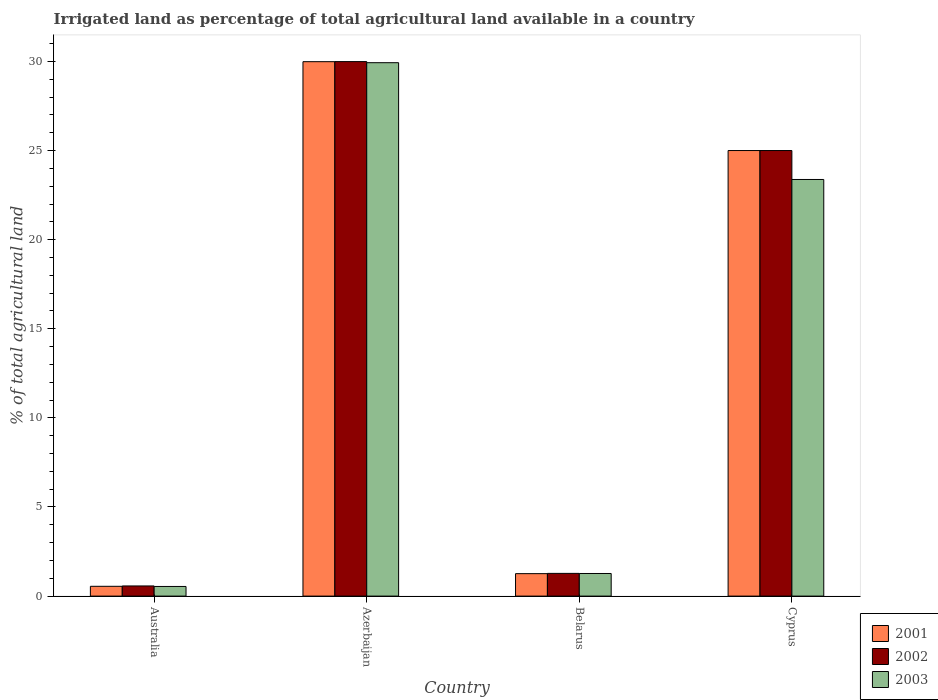Are the number of bars per tick equal to the number of legend labels?
Ensure brevity in your answer.  Yes. Are the number of bars on each tick of the X-axis equal?
Keep it short and to the point. Yes. How many bars are there on the 2nd tick from the right?
Provide a short and direct response. 3. What is the label of the 4th group of bars from the left?
Offer a very short reply. Cyprus. What is the percentage of irrigated land in 2002 in Belarus?
Your answer should be very brief. 1.27. Across all countries, what is the maximum percentage of irrigated land in 2001?
Your answer should be very brief. 29.99. Across all countries, what is the minimum percentage of irrigated land in 2003?
Keep it short and to the point. 0.54. In which country was the percentage of irrigated land in 2002 maximum?
Your answer should be compact. Azerbaijan. In which country was the percentage of irrigated land in 2001 minimum?
Offer a very short reply. Australia. What is the total percentage of irrigated land in 2001 in the graph?
Ensure brevity in your answer.  56.8. What is the difference between the percentage of irrigated land in 2002 in Australia and that in Cyprus?
Ensure brevity in your answer.  -24.43. What is the difference between the percentage of irrigated land in 2003 in Azerbaijan and the percentage of irrigated land in 2001 in Australia?
Keep it short and to the point. 29.38. What is the average percentage of irrigated land in 2001 per country?
Make the answer very short. 14.2. What is the difference between the percentage of irrigated land of/in 2002 and percentage of irrigated land of/in 2003 in Australia?
Give a very brief answer. 0.03. In how many countries, is the percentage of irrigated land in 2003 greater than 25 %?
Offer a terse response. 1. What is the ratio of the percentage of irrigated land in 2001 in Australia to that in Cyprus?
Keep it short and to the point. 0.02. Is the difference between the percentage of irrigated land in 2002 in Australia and Cyprus greater than the difference between the percentage of irrigated land in 2003 in Australia and Cyprus?
Your answer should be very brief. No. What is the difference between the highest and the second highest percentage of irrigated land in 2002?
Your answer should be compact. -4.99. What is the difference between the highest and the lowest percentage of irrigated land in 2001?
Provide a short and direct response. 29.44. Is the sum of the percentage of irrigated land in 2003 in Australia and Cyprus greater than the maximum percentage of irrigated land in 2001 across all countries?
Offer a very short reply. No. What does the 2nd bar from the right in Azerbaijan represents?
Give a very brief answer. 2002. How many bars are there?
Make the answer very short. 12. How many countries are there in the graph?
Give a very brief answer. 4. What is the difference between two consecutive major ticks on the Y-axis?
Provide a short and direct response. 5. Are the values on the major ticks of Y-axis written in scientific E-notation?
Offer a terse response. No. Does the graph contain any zero values?
Make the answer very short. No. How many legend labels are there?
Make the answer very short. 3. What is the title of the graph?
Ensure brevity in your answer.  Irrigated land as percentage of total agricultural land available in a country. Does "1966" appear as one of the legend labels in the graph?
Offer a terse response. No. What is the label or title of the X-axis?
Your response must be concise. Country. What is the label or title of the Y-axis?
Provide a short and direct response. % of total agricultural land. What is the % of total agricultural land of 2001 in Australia?
Offer a very short reply. 0.55. What is the % of total agricultural land of 2002 in Australia?
Offer a very short reply. 0.57. What is the % of total agricultural land of 2003 in Australia?
Your answer should be compact. 0.54. What is the % of total agricultural land of 2001 in Azerbaijan?
Offer a very short reply. 29.99. What is the % of total agricultural land in 2002 in Azerbaijan?
Keep it short and to the point. 29.99. What is the % of total agricultural land of 2003 in Azerbaijan?
Provide a succinct answer. 29.93. What is the % of total agricultural land of 2001 in Belarus?
Provide a succinct answer. 1.26. What is the % of total agricultural land in 2002 in Belarus?
Your response must be concise. 1.27. What is the % of total agricultural land in 2003 in Belarus?
Provide a succinct answer. 1.27. What is the % of total agricultural land of 2002 in Cyprus?
Provide a short and direct response. 25. What is the % of total agricultural land in 2003 in Cyprus?
Make the answer very short. 23.38. Across all countries, what is the maximum % of total agricultural land of 2001?
Your answer should be very brief. 29.99. Across all countries, what is the maximum % of total agricultural land in 2002?
Your answer should be very brief. 29.99. Across all countries, what is the maximum % of total agricultural land in 2003?
Your answer should be compact. 29.93. Across all countries, what is the minimum % of total agricultural land of 2001?
Your answer should be very brief. 0.55. Across all countries, what is the minimum % of total agricultural land of 2002?
Your answer should be very brief. 0.57. Across all countries, what is the minimum % of total agricultural land of 2003?
Your answer should be compact. 0.54. What is the total % of total agricultural land of 2001 in the graph?
Offer a very short reply. 56.8. What is the total % of total agricultural land of 2002 in the graph?
Keep it short and to the point. 56.83. What is the total % of total agricultural land of 2003 in the graph?
Give a very brief answer. 55.12. What is the difference between the % of total agricultural land of 2001 in Australia and that in Azerbaijan?
Offer a very short reply. -29.44. What is the difference between the % of total agricultural land of 2002 in Australia and that in Azerbaijan?
Your answer should be compact. -29.42. What is the difference between the % of total agricultural land of 2003 in Australia and that in Azerbaijan?
Your answer should be very brief. -29.39. What is the difference between the % of total agricultural land of 2001 in Australia and that in Belarus?
Your answer should be very brief. -0.71. What is the difference between the % of total agricultural land in 2002 in Australia and that in Belarus?
Ensure brevity in your answer.  -0.7. What is the difference between the % of total agricultural land in 2003 in Australia and that in Belarus?
Make the answer very short. -0.73. What is the difference between the % of total agricultural land of 2001 in Australia and that in Cyprus?
Your answer should be very brief. -24.45. What is the difference between the % of total agricultural land in 2002 in Australia and that in Cyprus?
Give a very brief answer. -24.43. What is the difference between the % of total agricultural land in 2003 in Australia and that in Cyprus?
Offer a terse response. -22.84. What is the difference between the % of total agricultural land of 2001 in Azerbaijan and that in Belarus?
Give a very brief answer. 28.73. What is the difference between the % of total agricultural land in 2002 in Azerbaijan and that in Belarus?
Make the answer very short. 28.72. What is the difference between the % of total agricultural land of 2003 in Azerbaijan and that in Belarus?
Make the answer very short. 28.66. What is the difference between the % of total agricultural land of 2001 in Azerbaijan and that in Cyprus?
Offer a very short reply. 4.99. What is the difference between the % of total agricultural land of 2002 in Azerbaijan and that in Cyprus?
Ensure brevity in your answer.  4.99. What is the difference between the % of total agricultural land of 2003 in Azerbaijan and that in Cyprus?
Offer a terse response. 6.55. What is the difference between the % of total agricultural land of 2001 in Belarus and that in Cyprus?
Give a very brief answer. -23.74. What is the difference between the % of total agricultural land in 2002 in Belarus and that in Cyprus?
Offer a terse response. -23.73. What is the difference between the % of total agricultural land in 2003 in Belarus and that in Cyprus?
Offer a terse response. -22.11. What is the difference between the % of total agricultural land in 2001 in Australia and the % of total agricultural land in 2002 in Azerbaijan?
Make the answer very short. -29.44. What is the difference between the % of total agricultural land in 2001 in Australia and the % of total agricultural land in 2003 in Azerbaijan?
Keep it short and to the point. -29.38. What is the difference between the % of total agricultural land in 2002 in Australia and the % of total agricultural land in 2003 in Azerbaijan?
Provide a succinct answer. -29.36. What is the difference between the % of total agricultural land of 2001 in Australia and the % of total agricultural land of 2002 in Belarus?
Make the answer very short. -0.72. What is the difference between the % of total agricultural land of 2001 in Australia and the % of total agricultural land of 2003 in Belarus?
Offer a terse response. -0.72. What is the difference between the % of total agricultural land in 2002 in Australia and the % of total agricultural land in 2003 in Belarus?
Keep it short and to the point. -0.7. What is the difference between the % of total agricultural land of 2001 in Australia and the % of total agricultural land of 2002 in Cyprus?
Provide a succinct answer. -24.45. What is the difference between the % of total agricultural land in 2001 in Australia and the % of total agricultural land in 2003 in Cyprus?
Your response must be concise. -22.83. What is the difference between the % of total agricultural land of 2002 in Australia and the % of total agricultural land of 2003 in Cyprus?
Your answer should be very brief. -22.81. What is the difference between the % of total agricultural land in 2001 in Azerbaijan and the % of total agricultural land in 2002 in Belarus?
Offer a terse response. 28.71. What is the difference between the % of total agricultural land in 2001 in Azerbaijan and the % of total agricultural land in 2003 in Belarus?
Your response must be concise. 28.72. What is the difference between the % of total agricultural land in 2002 in Azerbaijan and the % of total agricultural land in 2003 in Belarus?
Give a very brief answer. 28.72. What is the difference between the % of total agricultural land of 2001 in Azerbaijan and the % of total agricultural land of 2002 in Cyprus?
Your answer should be very brief. 4.99. What is the difference between the % of total agricultural land of 2001 in Azerbaijan and the % of total agricultural land of 2003 in Cyprus?
Provide a short and direct response. 6.61. What is the difference between the % of total agricultural land of 2002 in Azerbaijan and the % of total agricultural land of 2003 in Cyprus?
Your answer should be very brief. 6.61. What is the difference between the % of total agricultural land in 2001 in Belarus and the % of total agricultural land in 2002 in Cyprus?
Offer a very short reply. -23.74. What is the difference between the % of total agricultural land in 2001 in Belarus and the % of total agricultural land in 2003 in Cyprus?
Keep it short and to the point. -22.12. What is the difference between the % of total agricultural land in 2002 in Belarus and the % of total agricultural land in 2003 in Cyprus?
Provide a succinct answer. -22.1. What is the average % of total agricultural land of 2001 per country?
Offer a terse response. 14.2. What is the average % of total agricultural land in 2002 per country?
Provide a succinct answer. 14.21. What is the average % of total agricultural land in 2003 per country?
Ensure brevity in your answer.  13.78. What is the difference between the % of total agricultural land in 2001 and % of total agricultural land in 2002 in Australia?
Provide a short and direct response. -0.02. What is the difference between the % of total agricultural land in 2001 and % of total agricultural land in 2003 in Australia?
Your answer should be compact. 0.01. What is the difference between the % of total agricultural land of 2002 and % of total agricultural land of 2003 in Australia?
Give a very brief answer. 0.03. What is the difference between the % of total agricultural land in 2001 and % of total agricultural land in 2002 in Azerbaijan?
Your answer should be very brief. -0. What is the difference between the % of total agricultural land in 2001 and % of total agricultural land in 2003 in Azerbaijan?
Make the answer very short. 0.06. What is the difference between the % of total agricultural land of 2002 and % of total agricultural land of 2003 in Azerbaijan?
Your answer should be compact. 0.06. What is the difference between the % of total agricultural land of 2001 and % of total agricultural land of 2002 in Belarus?
Keep it short and to the point. -0.01. What is the difference between the % of total agricultural land of 2001 and % of total agricultural land of 2003 in Belarus?
Make the answer very short. -0.01. What is the difference between the % of total agricultural land of 2002 and % of total agricultural land of 2003 in Belarus?
Keep it short and to the point. 0.01. What is the difference between the % of total agricultural land of 2001 and % of total agricultural land of 2002 in Cyprus?
Keep it short and to the point. 0. What is the difference between the % of total agricultural land of 2001 and % of total agricultural land of 2003 in Cyprus?
Your answer should be compact. 1.62. What is the difference between the % of total agricultural land of 2002 and % of total agricultural land of 2003 in Cyprus?
Keep it short and to the point. 1.62. What is the ratio of the % of total agricultural land of 2001 in Australia to that in Azerbaijan?
Give a very brief answer. 0.02. What is the ratio of the % of total agricultural land in 2002 in Australia to that in Azerbaijan?
Your answer should be compact. 0.02. What is the ratio of the % of total agricultural land of 2003 in Australia to that in Azerbaijan?
Give a very brief answer. 0.02. What is the ratio of the % of total agricultural land of 2001 in Australia to that in Belarus?
Ensure brevity in your answer.  0.44. What is the ratio of the % of total agricultural land in 2002 in Australia to that in Belarus?
Provide a succinct answer. 0.45. What is the ratio of the % of total agricultural land of 2003 in Australia to that in Belarus?
Your response must be concise. 0.43. What is the ratio of the % of total agricultural land in 2001 in Australia to that in Cyprus?
Make the answer very short. 0.02. What is the ratio of the % of total agricultural land of 2002 in Australia to that in Cyprus?
Your answer should be very brief. 0.02. What is the ratio of the % of total agricultural land in 2003 in Australia to that in Cyprus?
Offer a very short reply. 0.02. What is the ratio of the % of total agricultural land of 2001 in Azerbaijan to that in Belarus?
Your response must be concise. 23.8. What is the ratio of the % of total agricultural land in 2002 in Azerbaijan to that in Belarus?
Give a very brief answer. 23.54. What is the ratio of the % of total agricultural land in 2003 in Azerbaijan to that in Belarus?
Your response must be concise. 23.59. What is the ratio of the % of total agricultural land in 2001 in Azerbaijan to that in Cyprus?
Ensure brevity in your answer.  1.2. What is the ratio of the % of total agricultural land of 2002 in Azerbaijan to that in Cyprus?
Your answer should be compact. 1.2. What is the ratio of the % of total agricultural land of 2003 in Azerbaijan to that in Cyprus?
Give a very brief answer. 1.28. What is the ratio of the % of total agricultural land of 2001 in Belarus to that in Cyprus?
Your response must be concise. 0.05. What is the ratio of the % of total agricultural land of 2002 in Belarus to that in Cyprus?
Offer a very short reply. 0.05. What is the ratio of the % of total agricultural land in 2003 in Belarus to that in Cyprus?
Keep it short and to the point. 0.05. What is the difference between the highest and the second highest % of total agricultural land of 2001?
Your response must be concise. 4.99. What is the difference between the highest and the second highest % of total agricultural land of 2002?
Provide a short and direct response. 4.99. What is the difference between the highest and the second highest % of total agricultural land in 2003?
Keep it short and to the point. 6.55. What is the difference between the highest and the lowest % of total agricultural land of 2001?
Ensure brevity in your answer.  29.44. What is the difference between the highest and the lowest % of total agricultural land in 2002?
Provide a short and direct response. 29.42. What is the difference between the highest and the lowest % of total agricultural land of 2003?
Your answer should be compact. 29.39. 